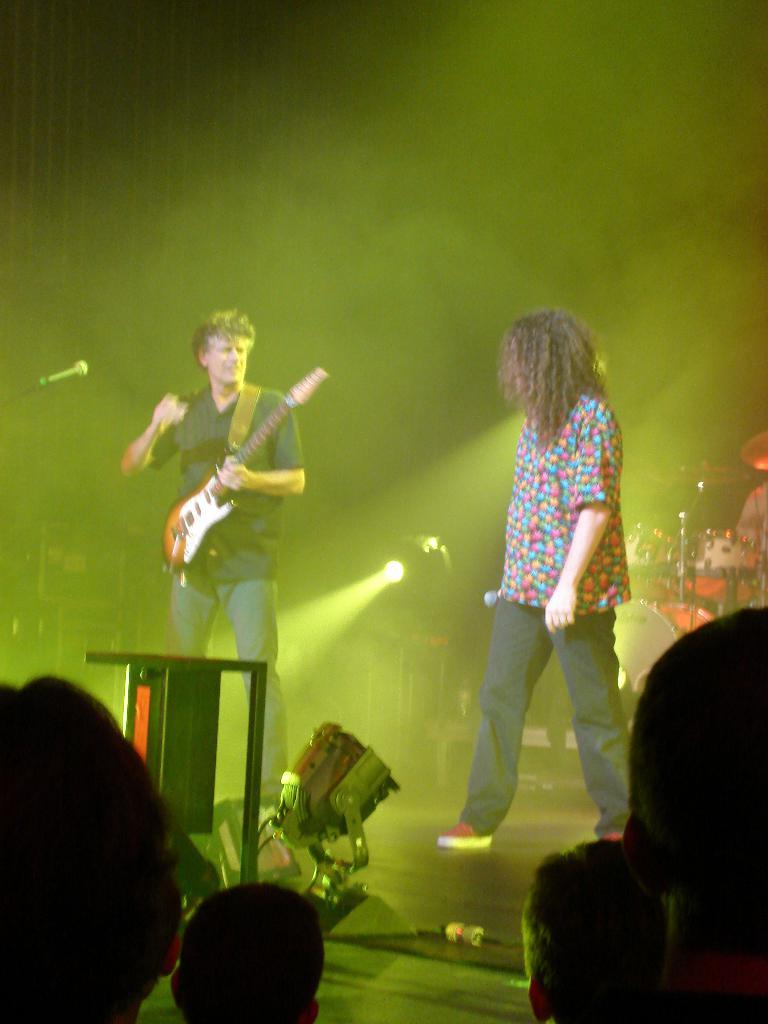What is the person in the image holding? The person is holding a guitar in the image. Are there any other people in the image besides the person with the guitar? Yes, there are people standing in the image. How many cherries are being divided among the people in the image? There are no cherries present in the image, so it is not possible to answer that question. 